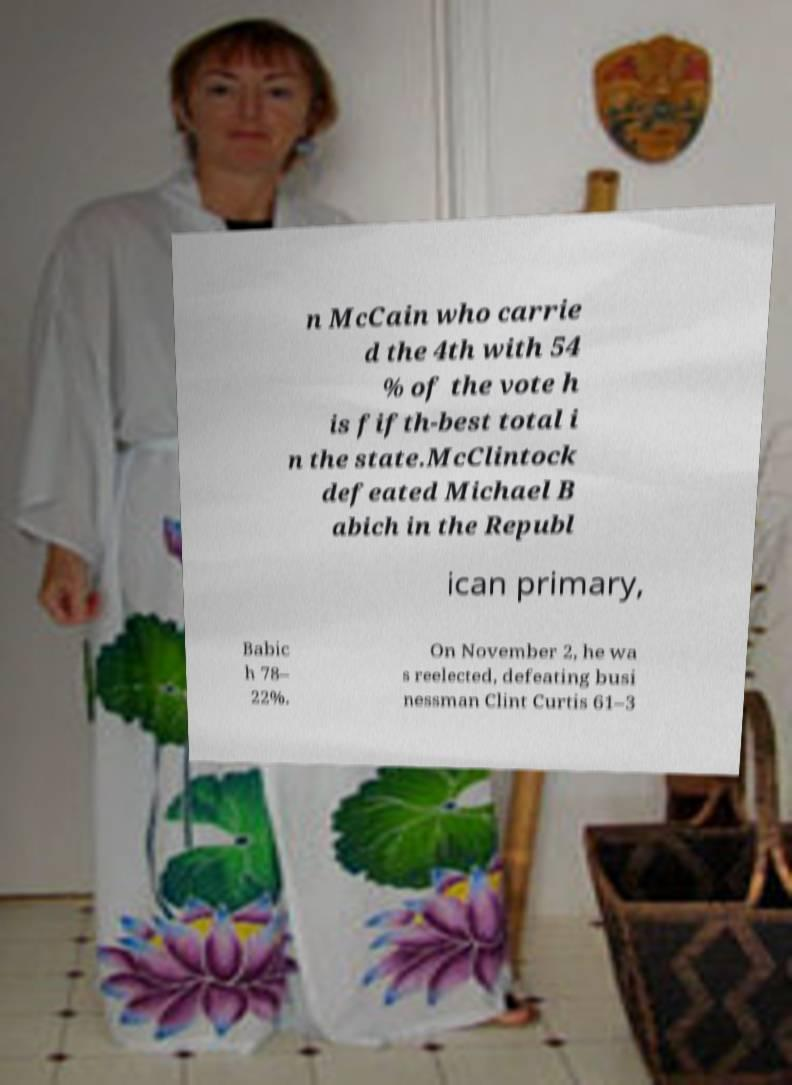Could you extract and type out the text from this image? n McCain who carrie d the 4th with 54 % of the vote h is fifth-best total i n the state.McClintock defeated Michael B abich in the Republ ican primary, Babic h 78– 22%. On November 2, he wa s reelected, defeating busi nessman Clint Curtis 61–3 